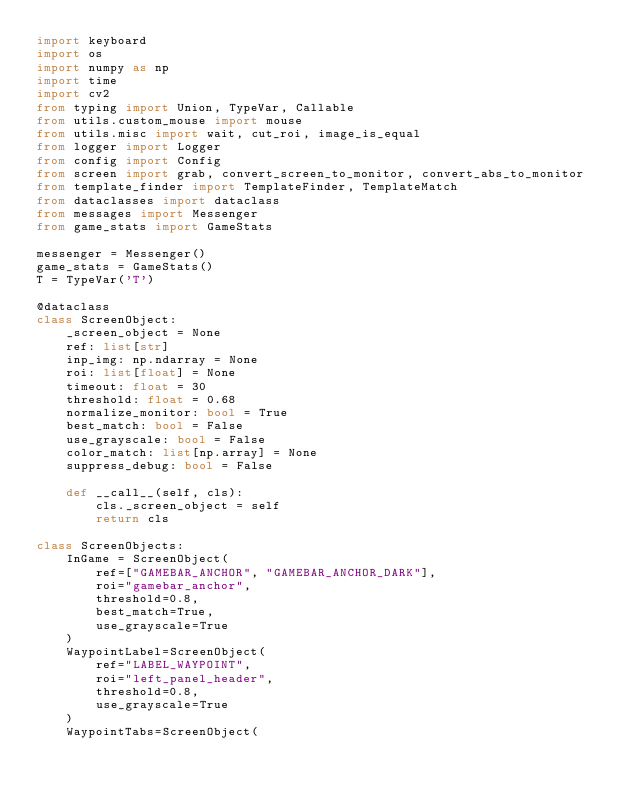Convert code to text. <code><loc_0><loc_0><loc_500><loc_500><_Python_>import keyboard
import os
import numpy as np
import time
import cv2
from typing import Union, TypeVar, Callable
from utils.custom_mouse import mouse
from utils.misc import wait, cut_roi, image_is_equal
from logger import Logger
from config import Config
from screen import grab, convert_screen_to_monitor, convert_abs_to_monitor
from template_finder import TemplateFinder, TemplateMatch
from dataclasses import dataclass
from messages import Messenger
from game_stats import GameStats

messenger = Messenger()
game_stats = GameStats()
T = TypeVar('T')

@dataclass
class ScreenObject:
    _screen_object = None
    ref: list[str]
    inp_img: np.ndarray = None
    roi: list[float] = None
    timeout: float = 30
    threshold: float = 0.68
    normalize_monitor: bool = True
    best_match: bool = False
    use_grayscale: bool = False
    color_match: list[np.array] = None
    suppress_debug: bool = False

    def __call__(self, cls):
        cls._screen_object = self
        return cls

class ScreenObjects:
    InGame = ScreenObject(
        ref=["GAMEBAR_ANCHOR", "GAMEBAR_ANCHOR_DARK"],
        roi="gamebar_anchor",
        threshold=0.8,
        best_match=True,
        use_grayscale=True
    )
    WaypointLabel=ScreenObject(
        ref="LABEL_WAYPOINT",
        roi="left_panel_header",
        threshold=0.8,
        use_grayscale=True
    )
    WaypointTabs=ScreenObject(</code> 